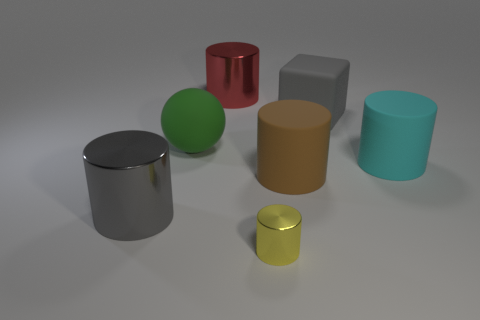Is there any other thing that is the same size as the yellow cylinder?
Your answer should be compact. No. There is a cylinder that is on the left side of the red metal cylinder; does it have the same color as the large block?
Offer a terse response. Yes. The red metal cylinder has what size?
Provide a short and direct response. Large. There is a metallic cylinder left of the shiny cylinder behind the gray shiny thing; how big is it?
Make the answer very short. Large. How many metal things are the same color as the large cube?
Your answer should be compact. 1. What number of tiny yellow cylinders are there?
Keep it short and to the point. 1. How many big blue objects are the same material as the brown thing?
Offer a terse response. 0. There is a red metallic object that is the same shape as the yellow object; what size is it?
Offer a very short reply. Large. What is the cyan cylinder made of?
Offer a terse response. Rubber. There is a cylinder that is in front of the big metal cylinder on the left side of the large metal cylinder behind the brown matte thing; what is it made of?
Your answer should be compact. Metal. 